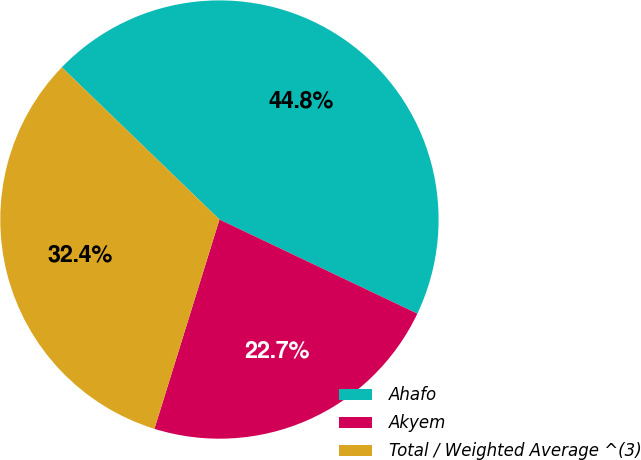Convert chart. <chart><loc_0><loc_0><loc_500><loc_500><pie_chart><fcel>Ahafo<fcel>Akyem<fcel>Total / Weighted Average ^(3)<nl><fcel>44.84%<fcel>22.73%<fcel>32.43%<nl></chart> 